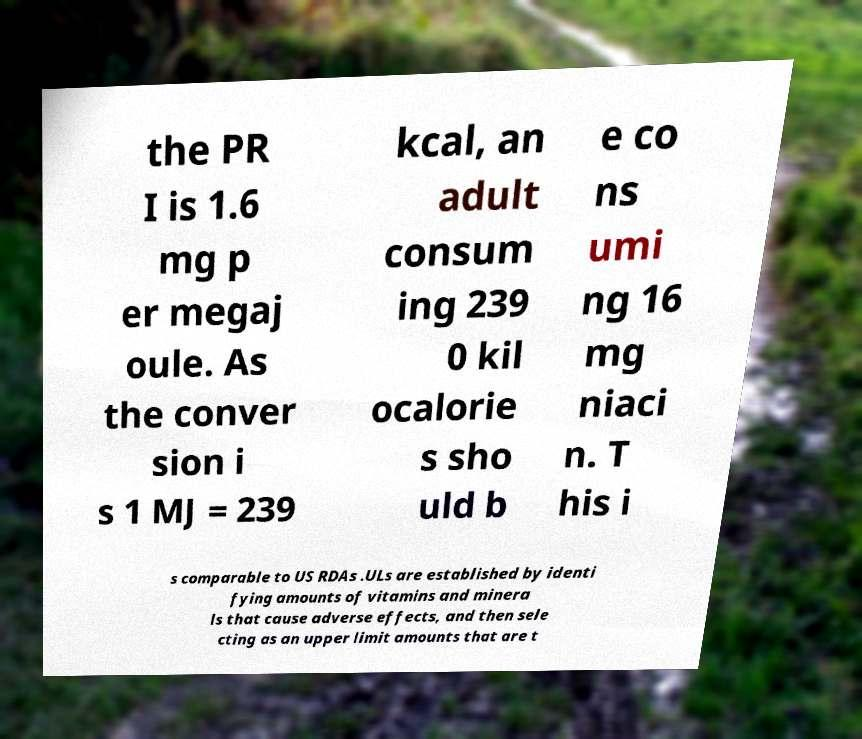Can you accurately transcribe the text from the provided image for me? the PR I is 1.6 mg p er megaj oule. As the conver sion i s 1 MJ = 239 kcal, an adult consum ing 239 0 kil ocalorie s sho uld b e co ns umi ng 16 mg niaci n. T his i s comparable to US RDAs .ULs are established by identi fying amounts of vitamins and minera ls that cause adverse effects, and then sele cting as an upper limit amounts that are t 